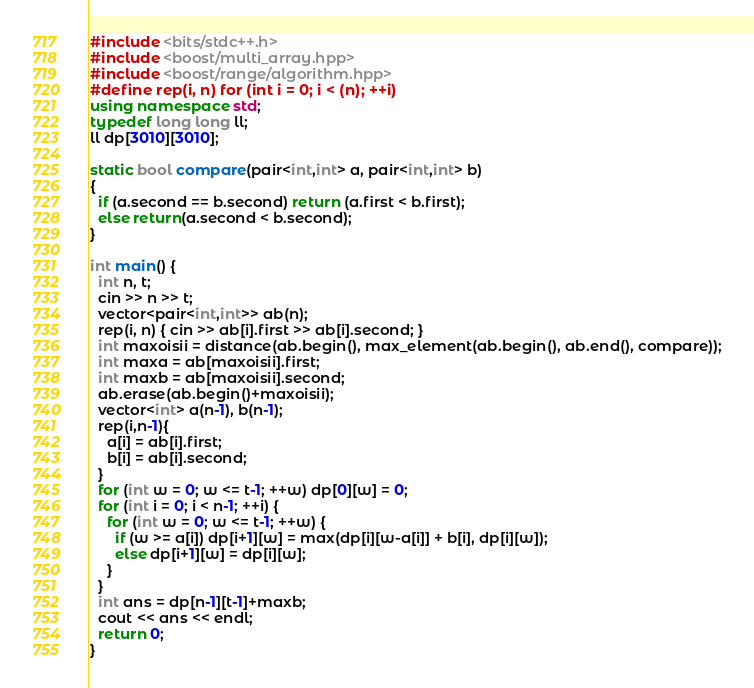Convert code to text. <code><loc_0><loc_0><loc_500><loc_500><_C++_>#include <bits/stdc++.h>
#include <boost/multi_array.hpp>
#include <boost/range/algorithm.hpp>
#define rep(i, n) for (int i = 0; i < (n); ++i)
using namespace std;
typedef long long ll;
ll dp[3010][3010];

static bool compare(pair<int,int> a, pair<int,int> b)
{
  if (a.second == b.second) return (a.first < b.first);
  else return(a.second < b.second);
}

int main() {
  int n, t;
  cin >> n >> t;
  vector<pair<int,int>> ab(n);
  rep(i, n) { cin >> ab[i].first >> ab[i].second; }
  int maxoisii = distance(ab.begin(), max_element(ab.begin(), ab.end(), compare));
  int maxa = ab[maxoisii].first;
  int maxb = ab[maxoisii].second;
  ab.erase(ab.begin()+maxoisii);
  vector<int> a(n-1), b(n-1);
  rep(i,n-1){
    a[i] = ab[i].first;
    b[i] = ab[i].second;
  }
  for (int w = 0; w <= t-1; ++w) dp[0][w] = 0;
  for (int i = 0; i < n-1; ++i) {
    for (int w = 0; w <= t-1; ++w) {
      if (w >= a[i]) dp[i+1][w] = max(dp[i][w-a[i]] + b[i], dp[i][w]);
      else dp[i+1][w] = dp[i][w];
    }
  }
  int ans = dp[n-1][t-1]+maxb;
  cout << ans << endl;
  return 0;
}
</code> 